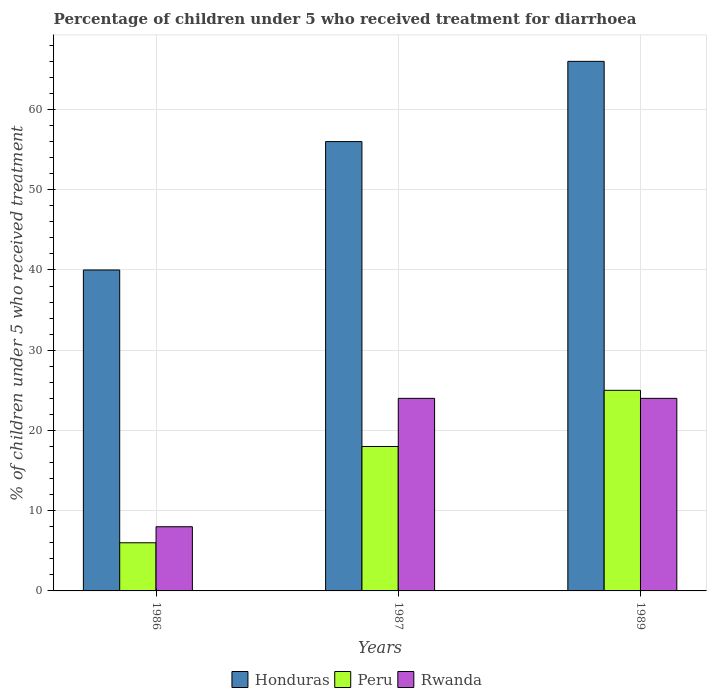How many different coloured bars are there?
Keep it short and to the point. 3. How many groups of bars are there?
Offer a terse response. 3. Are the number of bars per tick equal to the number of legend labels?
Provide a short and direct response. Yes. Are the number of bars on each tick of the X-axis equal?
Ensure brevity in your answer.  Yes. What is the label of the 1st group of bars from the left?
Provide a short and direct response. 1986. In how many cases, is the number of bars for a given year not equal to the number of legend labels?
Make the answer very short. 0. Across all years, what is the maximum percentage of children who received treatment for diarrhoea  in Honduras?
Provide a short and direct response. 66. In which year was the percentage of children who received treatment for diarrhoea  in Peru minimum?
Make the answer very short. 1986. What is the total percentage of children who received treatment for diarrhoea  in Honduras in the graph?
Make the answer very short. 162. What is the difference between the percentage of children who received treatment for diarrhoea  in Peru in 1986 and that in 1989?
Give a very brief answer. -19. What is the difference between the percentage of children who received treatment for diarrhoea  in Honduras in 1986 and the percentage of children who received treatment for diarrhoea  in Peru in 1987?
Keep it short and to the point. 22. What is the average percentage of children who received treatment for diarrhoea  in Rwanda per year?
Keep it short and to the point. 18.67. In the year 1989, what is the difference between the percentage of children who received treatment for diarrhoea  in Peru and percentage of children who received treatment for diarrhoea  in Honduras?
Your answer should be compact. -41. In how many years, is the percentage of children who received treatment for diarrhoea  in Rwanda greater than 14 %?
Your answer should be compact. 2. Is the percentage of children who received treatment for diarrhoea  in Peru in 1987 less than that in 1989?
Ensure brevity in your answer.  Yes. What is the difference between the highest and the lowest percentage of children who received treatment for diarrhoea  in Rwanda?
Give a very brief answer. 16. In how many years, is the percentage of children who received treatment for diarrhoea  in Peru greater than the average percentage of children who received treatment for diarrhoea  in Peru taken over all years?
Your answer should be compact. 2. What does the 3rd bar from the left in 1986 represents?
Make the answer very short. Rwanda. What does the 2nd bar from the right in 1987 represents?
Offer a very short reply. Peru. How many years are there in the graph?
Your answer should be very brief. 3. Are the values on the major ticks of Y-axis written in scientific E-notation?
Provide a succinct answer. No. How are the legend labels stacked?
Make the answer very short. Horizontal. What is the title of the graph?
Offer a terse response. Percentage of children under 5 who received treatment for diarrhoea. Does "Cambodia" appear as one of the legend labels in the graph?
Keep it short and to the point. No. What is the label or title of the X-axis?
Give a very brief answer. Years. What is the label or title of the Y-axis?
Your answer should be compact. % of children under 5 who received treatment. What is the % of children under 5 who received treatment of Honduras in 1986?
Provide a short and direct response. 40. What is the % of children under 5 who received treatment of Rwanda in 1986?
Offer a very short reply. 8. What is the % of children under 5 who received treatment in Honduras in 1987?
Your answer should be compact. 56. What is the % of children under 5 who received treatment of Rwanda in 1987?
Keep it short and to the point. 24. What is the % of children under 5 who received treatment in Peru in 1989?
Provide a short and direct response. 25. Across all years, what is the maximum % of children under 5 who received treatment in Rwanda?
Provide a short and direct response. 24. What is the total % of children under 5 who received treatment in Honduras in the graph?
Your answer should be compact. 162. What is the total % of children under 5 who received treatment in Rwanda in the graph?
Give a very brief answer. 56. What is the difference between the % of children under 5 who received treatment of Honduras in 1986 and that in 1987?
Provide a short and direct response. -16. What is the difference between the % of children under 5 who received treatment of Peru in 1986 and that in 1989?
Your answer should be very brief. -19. What is the difference between the % of children under 5 who received treatment in Rwanda in 1986 and that in 1989?
Offer a terse response. -16. What is the difference between the % of children under 5 who received treatment of Rwanda in 1987 and that in 1989?
Offer a very short reply. 0. What is the difference between the % of children under 5 who received treatment of Honduras in 1986 and the % of children under 5 who received treatment of Peru in 1987?
Give a very brief answer. 22. What is the difference between the % of children under 5 who received treatment in Peru in 1986 and the % of children under 5 who received treatment in Rwanda in 1987?
Offer a very short reply. -18. What is the difference between the % of children under 5 who received treatment of Peru in 1986 and the % of children under 5 who received treatment of Rwanda in 1989?
Your response must be concise. -18. What is the difference between the % of children under 5 who received treatment in Peru in 1987 and the % of children under 5 who received treatment in Rwanda in 1989?
Make the answer very short. -6. What is the average % of children under 5 who received treatment of Honduras per year?
Provide a succinct answer. 54. What is the average % of children under 5 who received treatment of Peru per year?
Your answer should be very brief. 16.33. What is the average % of children under 5 who received treatment in Rwanda per year?
Offer a terse response. 18.67. In the year 1987, what is the difference between the % of children under 5 who received treatment of Honduras and % of children under 5 who received treatment of Peru?
Provide a short and direct response. 38. In the year 1987, what is the difference between the % of children under 5 who received treatment of Honduras and % of children under 5 who received treatment of Rwanda?
Ensure brevity in your answer.  32. In the year 1989, what is the difference between the % of children under 5 who received treatment of Honduras and % of children under 5 who received treatment of Peru?
Your response must be concise. 41. In the year 1989, what is the difference between the % of children under 5 who received treatment of Honduras and % of children under 5 who received treatment of Rwanda?
Make the answer very short. 42. In the year 1989, what is the difference between the % of children under 5 who received treatment of Peru and % of children under 5 who received treatment of Rwanda?
Offer a very short reply. 1. What is the ratio of the % of children under 5 who received treatment of Honduras in 1986 to that in 1987?
Your answer should be very brief. 0.71. What is the ratio of the % of children under 5 who received treatment in Peru in 1986 to that in 1987?
Keep it short and to the point. 0.33. What is the ratio of the % of children under 5 who received treatment in Rwanda in 1986 to that in 1987?
Your answer should be very brief. 0.33. What is the ratio of the % of children under 5 who received treatment of Honduras in 1986 to that in 1989?
Ensure brevity in your answer.  0.61. What is the ratio of the % of children under 5 who received treatment of Peru in 1986 to that in 1989?
Your answer should be very brief. 0.24. What is the ratio of the % of children under 5 who received treatment of Rwanda in 1986 to that in 1989?
Keep it short and to the point. 0.33. What is the ratio of the % of children under 5 who received treatment of Honduras in 1987 to that in 1989?
Keep it short and to the point. 0.85. What is the ratio of the % of children under 5 who received treatment in Peru in 1987 to that in 1989?
Offer a very short reply. 0.72. What is the difference between the highest and the second highest % of children under 5 who received treatment of Honduras?
Offer a terse response. 10. What is the difference between the highest and the second highest % of children under 5 who received treatment in Peru?
Ensure brevity in your answer.  7. What is the difference between the highest and the lowest % of children under 5 who received treatment of Peru?
Make the answer very short. 19. 